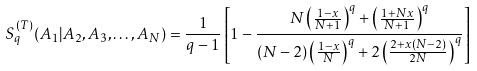Convert formula to latex. <formula><loc_0><loc_0><loc_500><loc_500>S ^ { ( T ) } _ { q } ( A _ { 1 } | A _ { 2 } , A _ { 3 } , \dots , A _ { N } ) = \frac { 1 } { q - 1 } \left [ 1 - \frac { N \left ( \frac { 1 - x } { N + 1 } \right ) ^ { q } + \left ( \frac { 1 + N x } { N + 1 } \right ) ^ { q } } { ( N - 2 ) \left ( \frac { 1 - x } { N } \right ) ^ { q } + 2 \left ( \frac { 2 + x ( N - 2 ) } { 2 N } \right ) ^ { q } } \right ]</formula> 